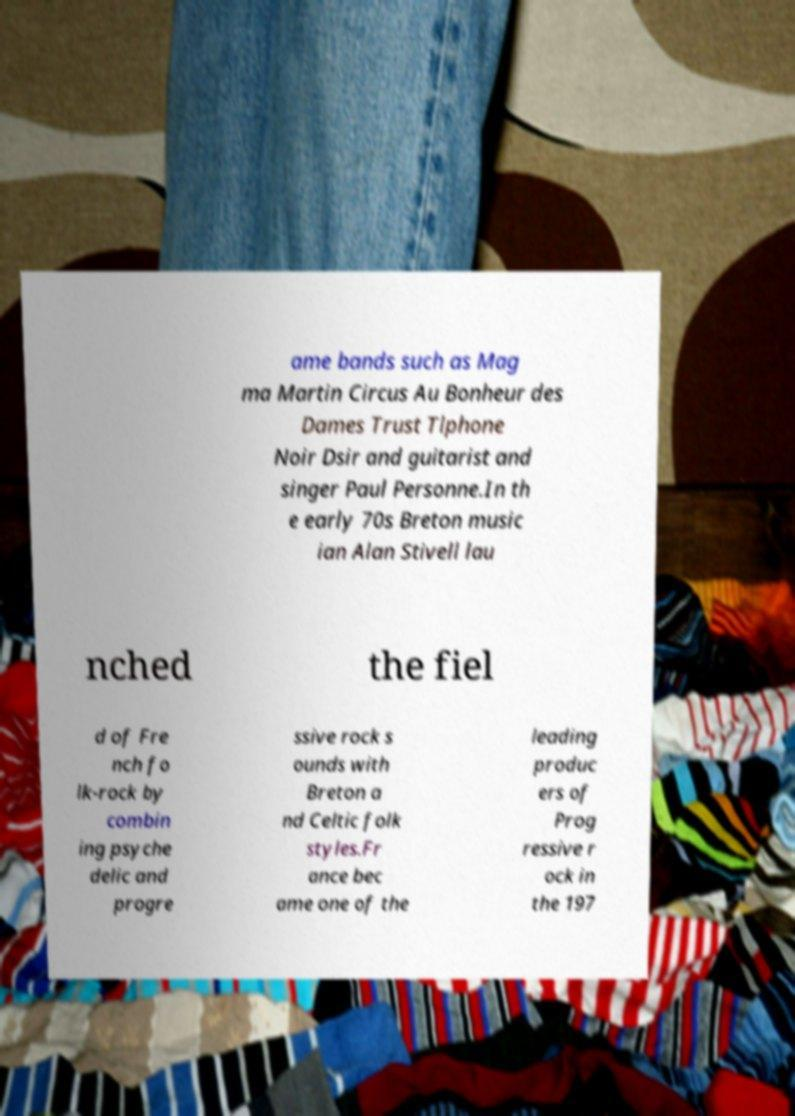Could you extract and type out the text from this image? ame bands such as Mag ma Martin Circus Au Bonheur des Dames Trust Tlphone Noir Dsir and guitarist and singer Paul Personne.In th e early 70s Breton music ian Alan Stivell lau nched the fiel d of Fre nch fo lk-rock by combin ing psyche delic and progre ssive rock s ounds with Breton a nd Celtic folk styles.Fr ance bec ame one of the leading produc ers of Prog ressive r ock in the 197 